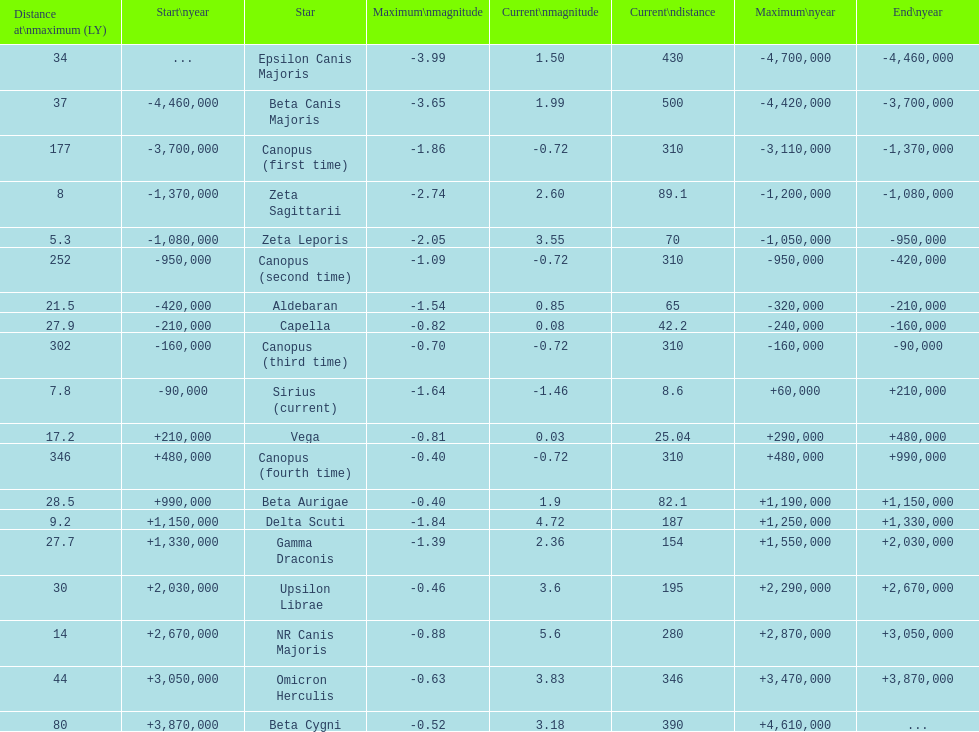How many stars have a distance at maximum of 30 light years or higher? 9. 